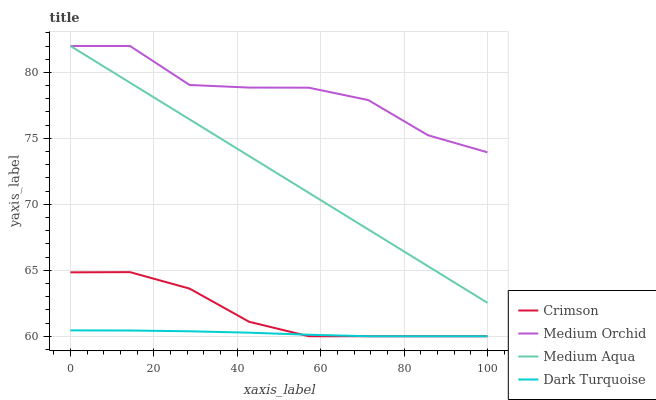Does Dark Turquoise have the minimum area under the curve?
Answer yes or no. Yes. Does Medium Orchid have the maximum area under the curve?
Answer yes or no. Yes. Does Medium Orchid have the minimum area under the curve?
Answer yes or no. No. Does Dark Turquoise have the maximum area under the curve?
Answer yes or no. No. Is Medium Aqua the smoothest?
Answer yes or no. Yes. Is Medium Orchid the roughest?
Answer yes or no. Yes. Is Dark Turquoise the smoothest?
Answer yes or no. No. Is Dark Turquoise the roughest?
Answer yes or no. No. Does Medium Orchid have the lowest value?
Answer yes or no. No. Does Dark Turquoise have the highest value?
Answer yes or no. No. Is Dark Turquoise less than Medium Aqua?
Answer yes or no. Yes. Is Medium Aqua greater than Dark Turquoise?
Answer yes or no. Yes. Does Dark Turquoise intersect Medium Aqua?
Answer yes or no. No. 